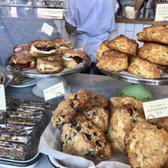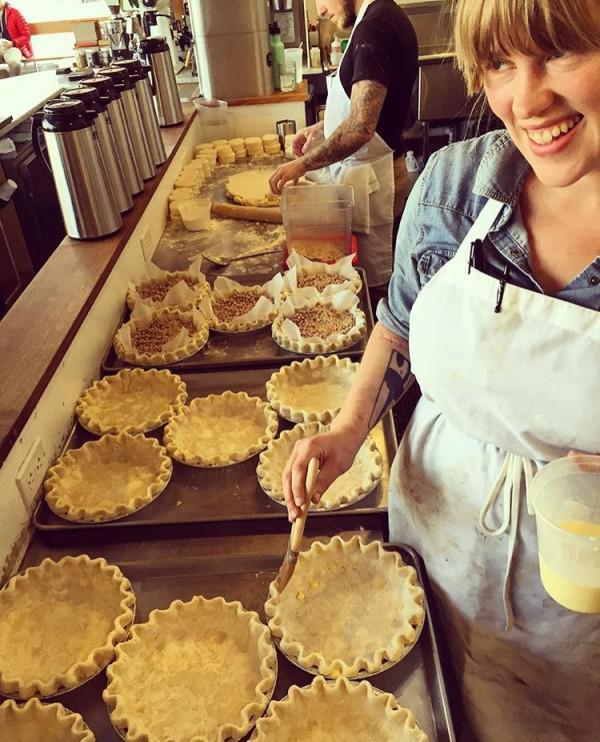The first image is the image on the left, the second image is the image on the right. Analyze the images presented: Is the assertion "There is a single green cake holder that contains  at least seven yellow and brown looking muffin tops." valid? Answer yes or no. No. The first image is the image on the left, the second image is the image on the right. For the images displayed, is the sentence "Each image contains a person behind a counter." factually correct? Answer yes or no. Yes. 